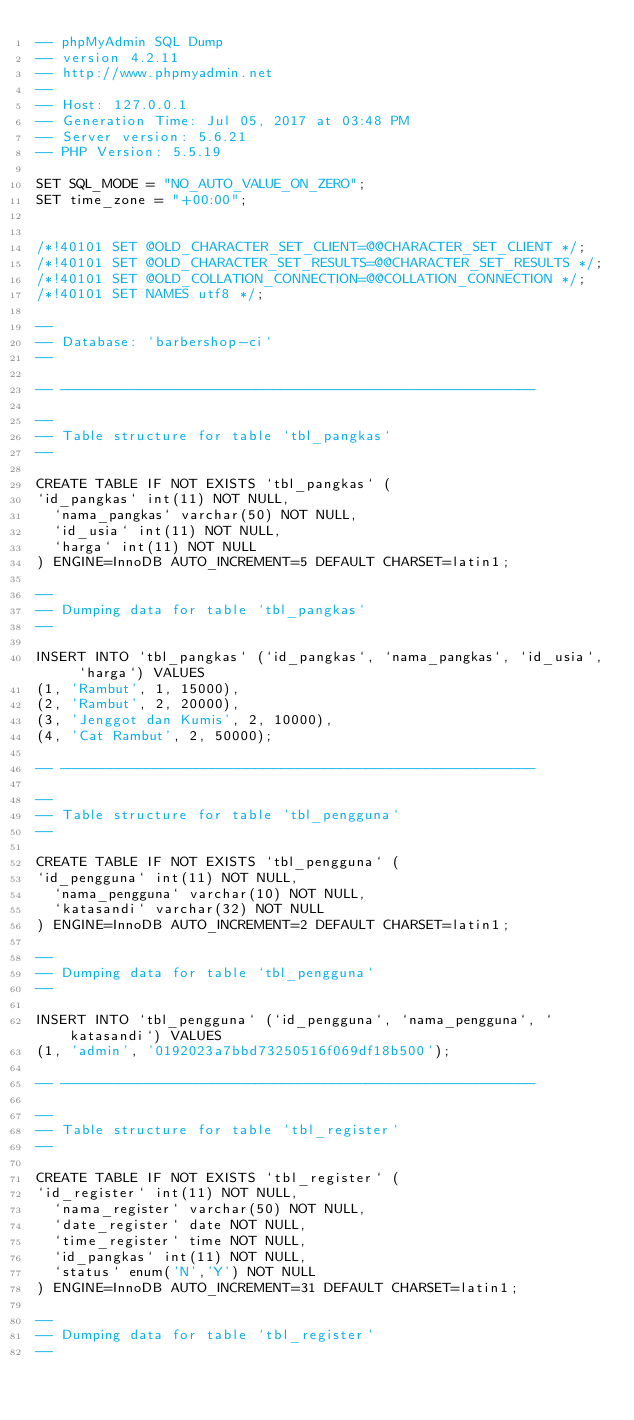Convert code to text. <code><loc_0><loc_0><loc_500><loc_500><_SQL_>-- phpMyAdmin SQL Dump
-- version 4.2.11
-- http://www.phpmyadmin.net
--
-- Host: 127.0.0.1
-- Generation Time: Jul 05, 2017 at 03:48 PM
-- Server version: 5.6.21
-- PHP Version: 5.5.19

SET SQL_MODE = "NO_AUTO_VALUE_ON_ZERO";
SET time_zone = "+00:00";


/*!40101 SET @OLD_CHARACTER_SET_CLIENT=@@CHARACTER_SET_CLIENT */;
/*!40101 SET @OLD_CHARACTER_SET_RESULTS=@@CHARACTER_SET_RESULTS */;
/*!40101 SET @OLD_COLLATION_CONNECTION=@@COLLATION_CONNECTION */;
/*!40101 SET NAMES utf8 */;

--
-- Database: `barbershop-ci`
--

-- --------------------------------------------------------

--
-- Table structure for table `tbl_pangkas`
--

CREATE TABLE IF NOT EXISTS `tbl_pangkas` (
`id_pangkas` int(11) NOT NULL,
  `nama_pangkas` varchar(50) NOT NULL,
  `id_usia` int(11) NOT NULL,
  `harga` int(11) NOT NULL
) ENGINE=InnoDB AUTO_INCREMENT=5 DEFAULT CHARSET=latin1;

--
-- Dumping data for table `tbl_pangkas`
--

INSERT INTO `tbl_pangkas` (`id_pangkas`, `nama_pangkas`, `id_usia`, `harga`) VALUES
(1, 'Rambut', 1, 15000),
(2, 'Rambut', 2, 20000),
(3, 'Jenggot dan Kumis', 2, 10000),
(4, 'Cat Rambut', 2, 50000);

-- --------------------------------------------------------

--
-- Table structure for table `tbl_pengguna`
--

CREATE TABLE IF NOT EXISTS `tbl_pengguna` (
`id_pengguna` int(11) NOT NULL,
  `nama_pengguna` varchar(10) NOT NULL,
  `katasandi` varchar(32) NOT NULL
) ENGINE=InnoDB AUTO_INCREMENT=2 DEFAULT CHARSET=latin1;

--
-- Dumping data for table `tbl_pengguna`
--

INSERT INTO `tbl_pengguna` (`id_pengguna`, `nama_pengguna`, `katasandi`) VALUES
(1, 'admin', '0192023a7bbd73250516f069df18b500');

-- --------------------------------------------------------

--
-- Table structure for table `tbl_register`
--

CREATE TABLE IF NOT EXISTS `tbl_register` (
`id_register` int(11) NOT NULL,
  `nama_register` varchar(50) NOT NULL,
  `date_register` date NOT NULL,
  `time_register` time NOT NULL,
  `id_pangkas` int(11) NOT NULL,
  `status` enum('N','Y') NOT NULL
) ENGINE=InnoDB AUTO_INCREMENT=31 DEFAULT CHARSET=latin1;

--
-- Dumping data for table `tbl_register`
--
</code> 